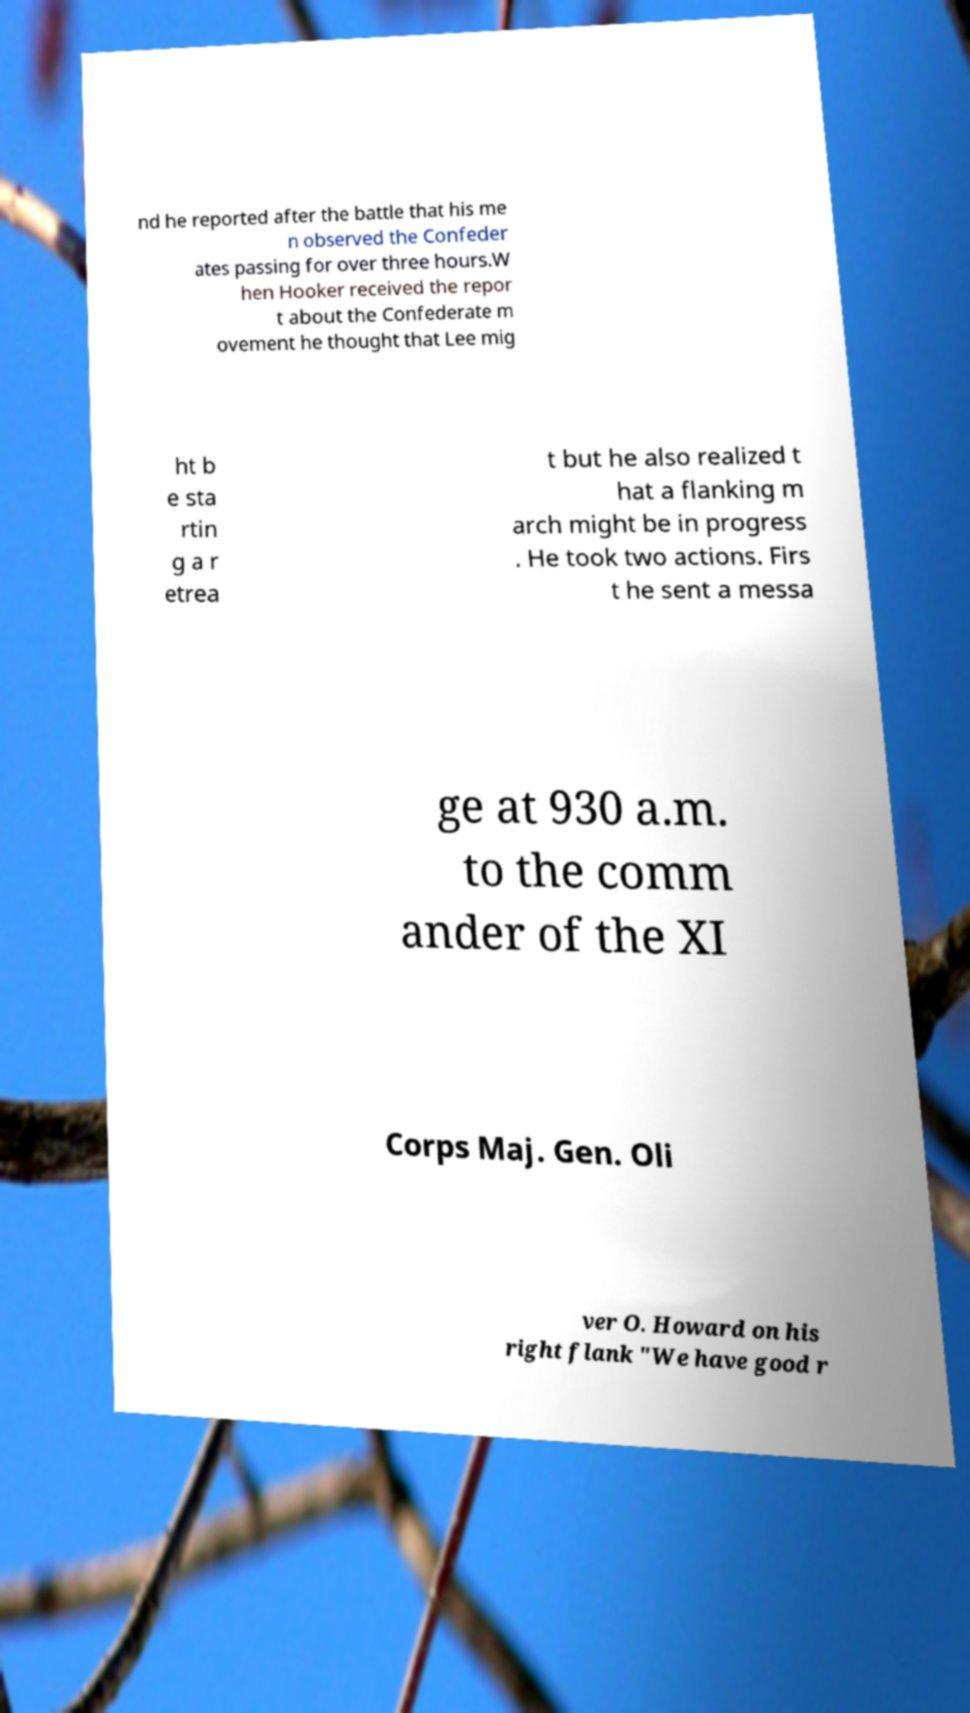For documentation purposes, I need the text within this image transcribed. Could you provide that? nd he reported after the battle that his me n observed the Confeder ates passing for over three hours.W hen Hooker received the repor t about the Confederate m ovement he thought that Lee mig ht b e sta rtin g a r etrea t but he also realized t hat a flanking m arch might be in progress . He took two actions. Firs t he sent a messa ge at 930 a.m. to the comm ander of the XI Corps Maj. Gen. Oli ver O. Howard on his right flank "We have good r 